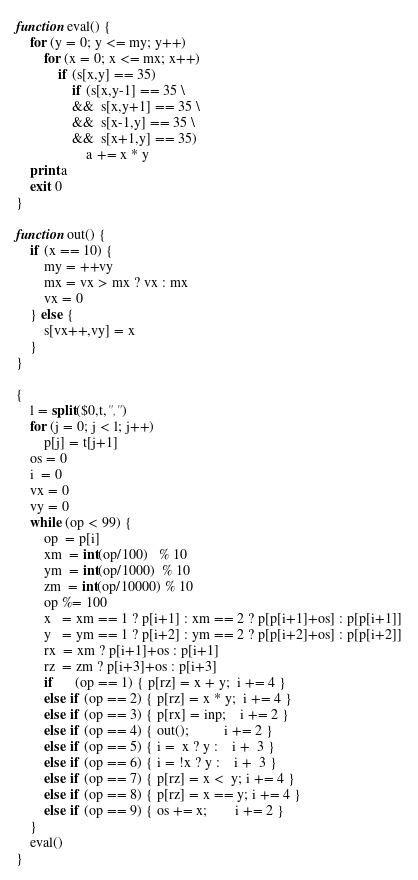Convert code to text. <code><loc_0><loc_0><loc_500><loc_500><_Awk_>function eval() {
    for (y = 0; y <= my; y++)
        for (x = 0; x <= mx; x++)
            if (s[x,y] == 35)
                if (s[x,y-1] == 35 \
                &&  s[x,y+1] == 35 \
                &&  s[x-1,y] == 35 \
                &&  s[x+1,y] == 35)
                    a += x * y
    print a
    exit 0
}

function out() {
    if (x == 10) {
        my = ++vy
        mx = vx > mx ? vx : mx
        vx = 0
    } else {
        s[vx++,vy] = x
    }
}

{
    l = split($0,t,",")
    for (j = 0; j < l; j++)
        p[j] = t[j+1]
    os = 0
    i  = 0
    vx = 0
    vy = 0
    while (op < 99) {
        op  = p[i]
        xm  = int(op/100)   % 10
        ym  = int(op/1000)  % 10
        zm  = int(op/10000) % 10
        op %= 100
        x   = xm == 1 ? p[i+1] : xm == 2 ? p[p[i+1]+os] : p[p[i+1]]
        y   = ym == 1 ? p[i+2] : ym == 2 ? p[p[i+2]+os] : p[p[i+2]]
        rx  = xm ? p[i+1]+os : p[i+1]
        rz  = zm ? p[i+3]+os : p[i+3]
        if      (op == 1) { p[rz] = x + y;  i += 4 }
        else if (op == 2) { p[rz] = x * y;  i += 4 }
        else if (op == 3) { p[rx] = inp;    i += 2 }
        else if (op == 4) { out();          i += 2 }
        else if (op == 5) { i =  x ? y :    i +  3 }
        else if (op == 6) { i = !x ? y :    i +  3 }
        else if (op == 7) { p[rz] = x <  y; i += 4 }
        else if (op == 8) { p[rz] = x == y; i += 4 }
        else if (op == 9) { os += x;        i += 2 }
    }
    eval()
}
</code> 